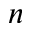Convert formula to latex. <formula><loc_0><loc_0><loc_500><loc_500>n</formula> 